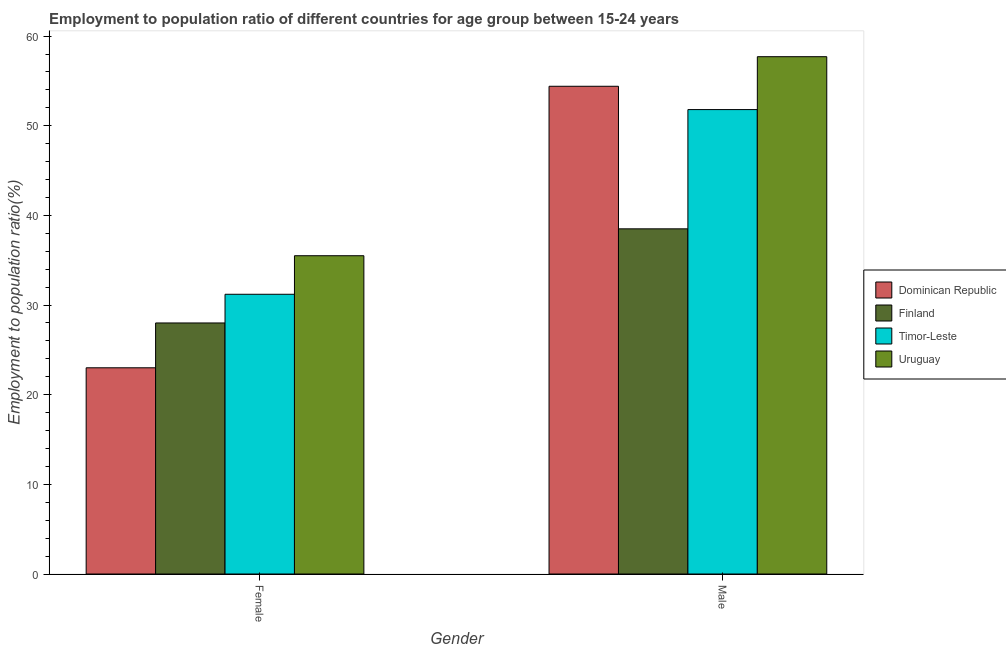Are the number of bars per tick equal to the number of legend labels?
Make the answer very short. Yes. Are the number of bars on each tick of the X-axis equal?
Make the answer very short. Yes. How many bars are there on the 1st tick from the left?
Ensure brevity in your answer.  4. What is the employment to population ratio(female) in Uruguay?
Ensure brevity in your answer.  35.5. Across all countries, what is the maximum employment to population ratio(female)?
Offer a terse response. 35.5. Across all countries, what is the minimum employment to population ratio(female)?
Provide a succinct answer. 23. In which country was the employment to population ratio(female) maximum?
Keep it short and to the point. Uruguay. In which country was the employment to population ratio(female) minimum?
Offer a terse response. Dominican Republic. What is the total employment to population ratio(male) in the graph?
Your answer should be very brief. 202.4. What is the difference between the employment to population ratio(male) in Uruguay and the employment to population ratio(female) in Dominican Republic?
Ensure brevity in your answer.  34.7. What is the average employment to population ratio(female) per country?
Make the answer very short. 29.43. What is the difference between the employment to population ratio(male) and employment to population ratio(female) in Uruguay?
Offer a terse response. 22.2. What is the ratio of the employment to population ratio(female) in Dominican Republic to that in Uruguay?
Make the answer very short. 0.65. In how many countries, is the employment to population ratio(male) greater than the average employment to population ratio(male) taken over all countries?
Offer a terse response. 3. What does the 4th bar from the left in Male represents?
Make the answer very short. Uruguay. What does the 4th bar from the right in Male represents?
Offer a very short reply. Dominican Republic. How many bars are there?
Offer a very short reply. 8. Does the graph contain grids?
Make the answer very short. No. How are the legend labels stacked?
Offer a very short reply. Vertical. What is the title of the graph?
Provide a short and direct response. Employment to population ratio of different countries for age group between 15-24 years. What is the Employment to population ratio(%) in Dominican Republic in Female?
Provide a short and direct response. 23. What is the Employment to population ratio(%) of Finland in Female?
Ensure brevity in your answer.  28. What is the Employment to population ratio(%) of Timor-Leste in Female?
Ensure brevity in your answer.  31.2. What is the Employment to population ratio(%) of Uruguay in Female?
Your response must be concise. 35.5. What is the Employment to population ratio(%) of Dominican Republic in Male?
Provide a succinct answer. 54.4. What is the Employment to population ratio(%) in Finland in Male?
Ensure brevity in your answer.  38.5. What is the Employment to population ratio(%) in Timor-Leste in Male?
Keep it short and to the point. 51.8. What is the Employment to population ratio(%) in Uruguay in Male?
Provide a succinct answer. 57.7. Across all Gender, what is the maximum Employment to population ratio(%) in Dominican Republic?
Your response must be concise. 54.4. Across all Gender, what is the maximum Employment to population ratio(%) in Finland?
Give a very brief answer. 38.5. Across all Gender, what is the maximum Employment to population ratio(%) of Timor-Leste?
Make the answer very short. 51.8. Across all Gender, what is the maximum Employment to population ratio(%) of Uruguay?
Keep it short and to the point. 57.7. Across all Gender, what is the minimum Employment to population ratio(%) of Timor-Leste?
Your answer should be very brief. 31.2. Across all Gender, what is the minimum Employment to population ratio(%) in Uruguay?
Your answer should be very brief. 35.5. What is the total Employment to population ratio(%) of Dominican Republic in the graph?
Ensure brevity in your answer.  77.4. What is the total Employment to population ratio(%) in Finland in the graph?
Provide a short and direct response. 66.5. What is the total Employment to population ratio(%) in Timor-Leste in the graph?
Your answer should be very brief. 83. What is the total Employment to population ratio(%) of Uruguay in the graph?
Ensure brevity in your answer.  93.2. What is the difference between the Employment to population ratio(%) in Dominican Republic in Female and that in Male?
Give a very brief answer. -31.4. What is the difference between the Employment to population ratio(%) of Finland in Female and that in Male?
Give a very brief answer. -10.5. What is the difference between the Employment to population ratio(%) of Timor-Leste in Female and that in Male?
Provide a short and direct response. -20.6. What is the difference between the Employment to population ratio(%) of Uruguay in Female and that in Male?
Keep it short and to the point. -22.2. What is the difference between the Employment to population ratio(%) in Dominican Republic in Female and the Employment to population ratio(%) in Finland in Male?
Your answer should be very brief. -15.5. What is the difference between the Employment to population ratio(%) in Dominican Republic in Female and the Employment to population ratio(%) in Timor-Leste in Male?
Your response must be concise. -28.8. What is the difference between the Employment to population ratio(%) in Dominican Republic in Female and the Employment to population ratio(%) in Uruguay in Male?
Offer a terse response. -34.7. What is the difference between the Employment to population ratio(%) in Finland in Female and the Employment to population ratio(%) in Timor-Leste in Male?
Give a very brief answer. -23.8. What is the difference between the Employment to population ratio(%) of Finland in Female and the Employment to population ratio(%) of Uruguay in Male?
Your response must be concise. -29.7. What is the difference between the Employment to population ratio(%) of Timor-Leste in Female and the Employment to population ratio(%) of Uruguay in Male?
Provide a succinct answer. -26.5. What is the average Employment to population ratio(%) of Dominican Republic per Gender?
Offer a terse response. 38.7. What is the average Employment to population ratio(%) of Finland per Gender?
Ensure brevity in your answer.  33.25. What is the average Employment to population ratio(%) in Timor-Leste per Gender?
Your answer should be compact. 41.5. What is the average Employment to population ratio(%) in Uruguay per Gender?
Give a very brief answer. 46.6. What is the difference between the Employment to population ratio(%) of Dominican Republic and Employment to population ratio(%) of Finland in Female?
Ensure brevity in your answer.  -5. What is the difference between the Employment to population ratio(%) of Dominican Republic and Employment to population ratio(%) of Timor-Leste in Female?
Offer a very short reply. -8.2. What is the difference between the Employment to population ratio(%) in Dominican Republic and Employment to population ratio(%) in Uruguay in Female?
Give a very brief answer. -12.5. What is the difference between the Employment to population ratio(%) in Finland and Employment to population ratio(%) in Timor-Leste in Female?
Your answer should be very brief. -3.2. What is the difference between the Employment to population ratio(%) of Timor-Leste and Employment to population ratio(%) of Uruguay in Female?
Your answer should be very brief. -4.3. What is the difference between the Employment to population ratio(%) in Dominican Republic and Employment to population ratio(%) in Finland in Male?
Provide a short and direct response. 15.9. What is the difference between the Employment to population ratio(%) of Finland and Employment to population ratio(%) of Timor-Leste in Male?
Your answer should be compact. -13.3. What is the difference between the Employment to population ratio(%) of Finland and Employment to population ratio(%) of Uruguay in Male?
Your answer should be compact. -19.2. What is the difference between the Employment to population ratio(%) in Timor-Leste and Employment to population ratio(%) in Uruguay in Male?
Make the answer very short. -5.9. What is the ratio of the Employment to population ratio(%) in Dominican Republic in Female to that in Male?
Give a very brief answer. 0.42. What is the ratio of the Employment to population ratio(%) of Finland in Female to that in Male?
Make the answer very short. 0.73. What is the ratio of the Employment to population ratio(%) in Timor-Leste in Female to that in Male?
Your response must be concise. 0.6. What is the ratio of the Employment to population ratio(%) in Uruguay in Female to that in Male?
Keep it short and to the point. 0.62. What is the difference between the highest and the second highest Employment to population ratio(%) in Dominican Republic?
Offer a very short reply. 31.4. What is the difference between the highest and the second highest Employment to population ratio(%) in Timor-Leste?
Keep it short and to the point. 20.6. What is the difference between the highest and the second highest Employment to population ratio(%) of Uruguay?
Provide a short and direct response. 22.2. What is the difference between the highest and the lowest Employment to population ratio(%) in Dominican Republic?
Provide a succinct answer. 31.4. What is the difference between the highest and the lowest Employment to population ratio(%) in Finland?
Offer a terse response. 10.5. What is the difference between the highest and the lowest Employment to population ratio(%) of Timor-Leste?
Ensure brevity in your answer.  20.6. What is the difference between the highest and the lowest Employment to population ratio(%) in Uruguay?
Make the answer very short. 22.2. 